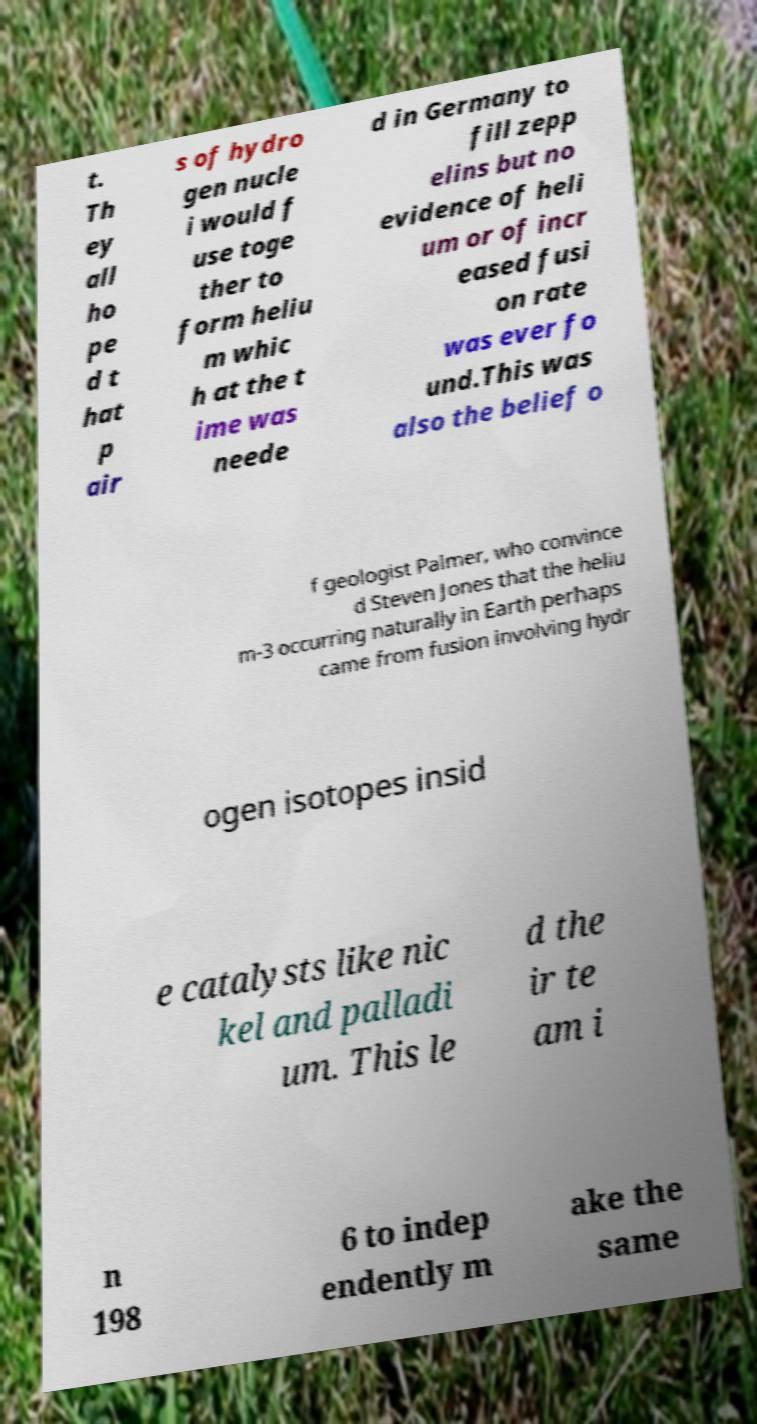Could you extract and type out the text from this image? t. Th ey all ho pe d t hat p air s of hydro gen nucle i would f use toge ther to form heliu m whic h at the t ime was neede d in Germany to fill zepp elins but no evidence of heli um or of incr eased fusi on rate was ever fo und.This was also the belief o f geologist Palmer, who convince d Steven Jones that the heliu m-3 occurring naturally in Earth perhaps came from fusion involving hydr ogen isotopes insid e catalysts like nic kel and palladi um. This le d the ir te am i n 198 6 to indep endently m ake the same 